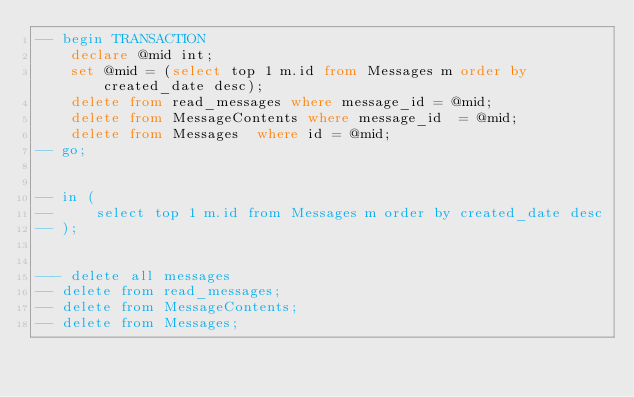Convert code to text. <code><loc_0><loc_0><loc_500><loc_500><_SQL_>-- begin TRANSACTION
    declare @mid int;
    set @mid = (select top 1 m.id from Messages m order by created_date desc);
    delete from read_messages where message_id = @mid;
    delete from MessageContents where message_id  = @mid;
    delete from Messages  where id = @mid;
-- go;


-- in (
--     select top 1 m.id from Messages m order by created_date desc   
-- );


--- delete all messages 
-- delete from read_messages;
-- delete from MessageContents;
-- delete from Messages;

</code> 